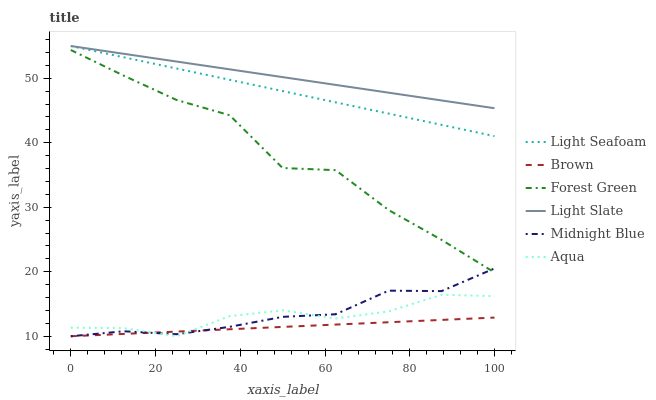Does Brown have the minimum area under the curve?
Answer yes or no. Yes. Does Light Slate have the maximum area under the curve?
Answer yes or no. Yes. Does Midnight Blue have the minimum area under the curve?
Answer yes or no. No. Does Midnight Blue have the maximum area under the curve?
Answer yes or no. No. Is Light Seafoam the smoothest?
Answer yes or no. Yes. Is Forest Green the roughest?
Answer yes or no. Yes. Is Midnight Blue the smoothest?
Answer yes or no. No. Is Midnight Blue the roughest?
Answer yes or no. No. Does Light Slate have the lowest value?
Answer yes or no. No. Does Light Seafoam have the highest value?
Answer yes or no. Yes. Does Midnight Blue have the highest value?
Answer yes or no. No. Is Forest Green less than Light Slate?
Answer yes or no. Yes. Is Forest Green greater than Brown?
Answer yes or no. Yes. Does Forest Green intersect Light Slate?
Answer yes or no. No. 